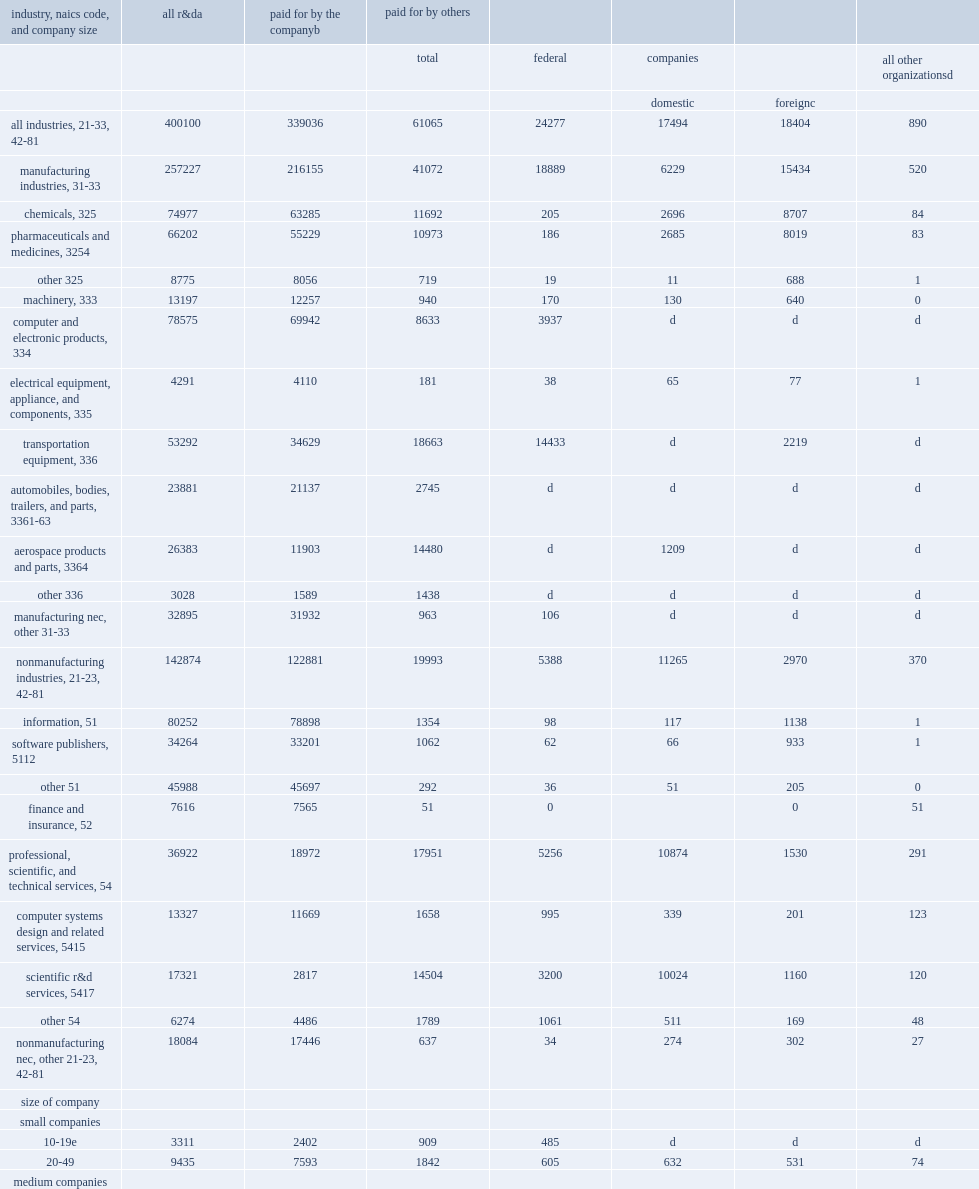In 2017, how many million dollars did companies in manufacturing industries perform of domestic r&d? 257227.0. In 2017, how many percentage points did companies in manufacturing industries perform of domestic r&d? 0.642907. How many million dollars did companies in nonmanufacturing industries perform of domestic r&d in 2017? 142874.0. How many percentage points did companies in nonmanufacturing industries perform of total domestic r&d performance? 0.357096. Parse the full table. {'header': ['industry, naics code, and company size', 'all r&da', 'paid for by the companyb', 'paid for by others', '', '', '', ''], 'rows': [['', '', '', 'total', 'federal', 'companies', '', 'all other organizationsd'], ['', '', '', '', '', 'domestic', 'foreignc', ''], ['all industries, 21-33, 42-81', '400100', '339036', '61065', '24277', '17494', '18404', '890'], ['manufacturing industries, 31-33', '257227', '216155', '41072', '18889', '6229', '15434', '520'], ['chemicals, 325', '74977', '63285', '11692', '205', '2696', '8707', '84'], ['pharmaceuticals and medicines, 3254', '66202', '55229', '10973', '186', '2685', '8019', '83'], ['other 325', '8775', '8056', '719', '19', '11', '688', '1'], ['machinery, 333', '13197', '12257', '940', '170', '130', '640', '0'], ['computer and electronic products, 334', '78575', '69942', '8633', '3937', 'd', 'd', 'd'], ['electrical equipment, appliance, and components, 335', '4291', '4110', '181', '38', '65', '77', '1'], ['transportation equipment, 336', '53292', '34629', '18663', '14433', 'd', '2219', 'd'], ['automobiles, bodies, trailers, and parts, 3361-63', '23881', '21137', '2745', 'd', 'd', 'd', 'd'], ['aerospace products and parts, 3364', '26383', '11903', '14480', 'd', '1209', 'd', 'd'], ['other 336', '3028', '1589', '1438', 'd', 'd', 'd', 'd'], ['manufacturing nec, other 31-33', '32895', '31932', '963', '106', 'd', 'd', 'd'], ['nonmanufacturing industries, 21-23, 42-81', '142874', '122881', '19993', '5388', '11265', '2970', '370'], ['information, 51', '80252', '78898', '1354', '98', '117', '1138', '1'], ['software publishers, 5112', '34264', '33201', '1062', '62', '66', '933', '1'], ['other 51', '45988', '45697', '292', '36', '51', '205', '0'], ['finance and insurance, 52', '7616', '7565', '51', '0', '', '0', '51'], ['professional, scientific, and technical services, 54', '36922', '18972', '17951', '5256', '10874', '1530', '291'], ['computer systems design and related services, 5415', '13327', '11669', '1658', '995', '339', '201', '123'], ['scientific r&d services, 5417', '17321', '2817', '14504', '3200', '10024', '1160', '120'], ['other 54', '6274', '4486', '1789', '1061', '511', '169', '48'], ['nonmanufacturing nec, other 21-23, 42-81', '18084', '17446', '637', '34', '274', '302', '27'], ['size of company', '', '', '', '', '', '', ''], ['small companies', '', '', '', '', '', '', ''], ['10-19e', '3311', '2402', '909', '485', 'd', 'd', 'd'], ['20-49', '9435', '7593', '1842', '605', '632', '531', '74'], ['medium companies', '', '', '', '', '', '', ''], ['50-99', '10141', '8070', '2071', '659', '668', '599', '145'], ['100-249', '17216', '13514', '3703', '1241', '866', '1524', '72'], ['large companies', '', '', '', '', '', '', ''], ['250-499', '14103', '11773', '2331', '592', '834', '863', '42'], ['500-999', '17871', '16295', '1576', '221', '311', '1038', '6'], ['1,000-4,999', '65112', '52341', '12771', '1461', '2724', '8531', '55'], ['5,000-9,999', '40198', '32701', '7497', '1525', '4938', '1011', '23'], ['10,000-24,999', '73485', '63415', '10070', '3514', '2627', '3917', '12'], ['25,000 or more', '149227', '130931', '18295', '13976', 'd', 'd', 'd']]} 